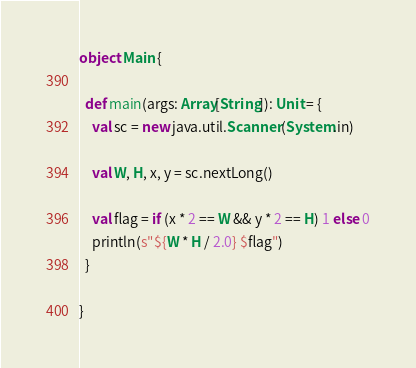<code> <loc_0><loc_0><loc_500><loc_500><_Scala_>object Main {

  def main(args: Array[String]): Unit = {
    val sc = new java.util.Scanner(System.in)

    val W, H, x, y = sc.nextLong()

    val flag = if (x * 2 == W && y * 2 == H) 1 else 0
    println(s"${W * H / 2.0} $flag")
  }

}

</code> 